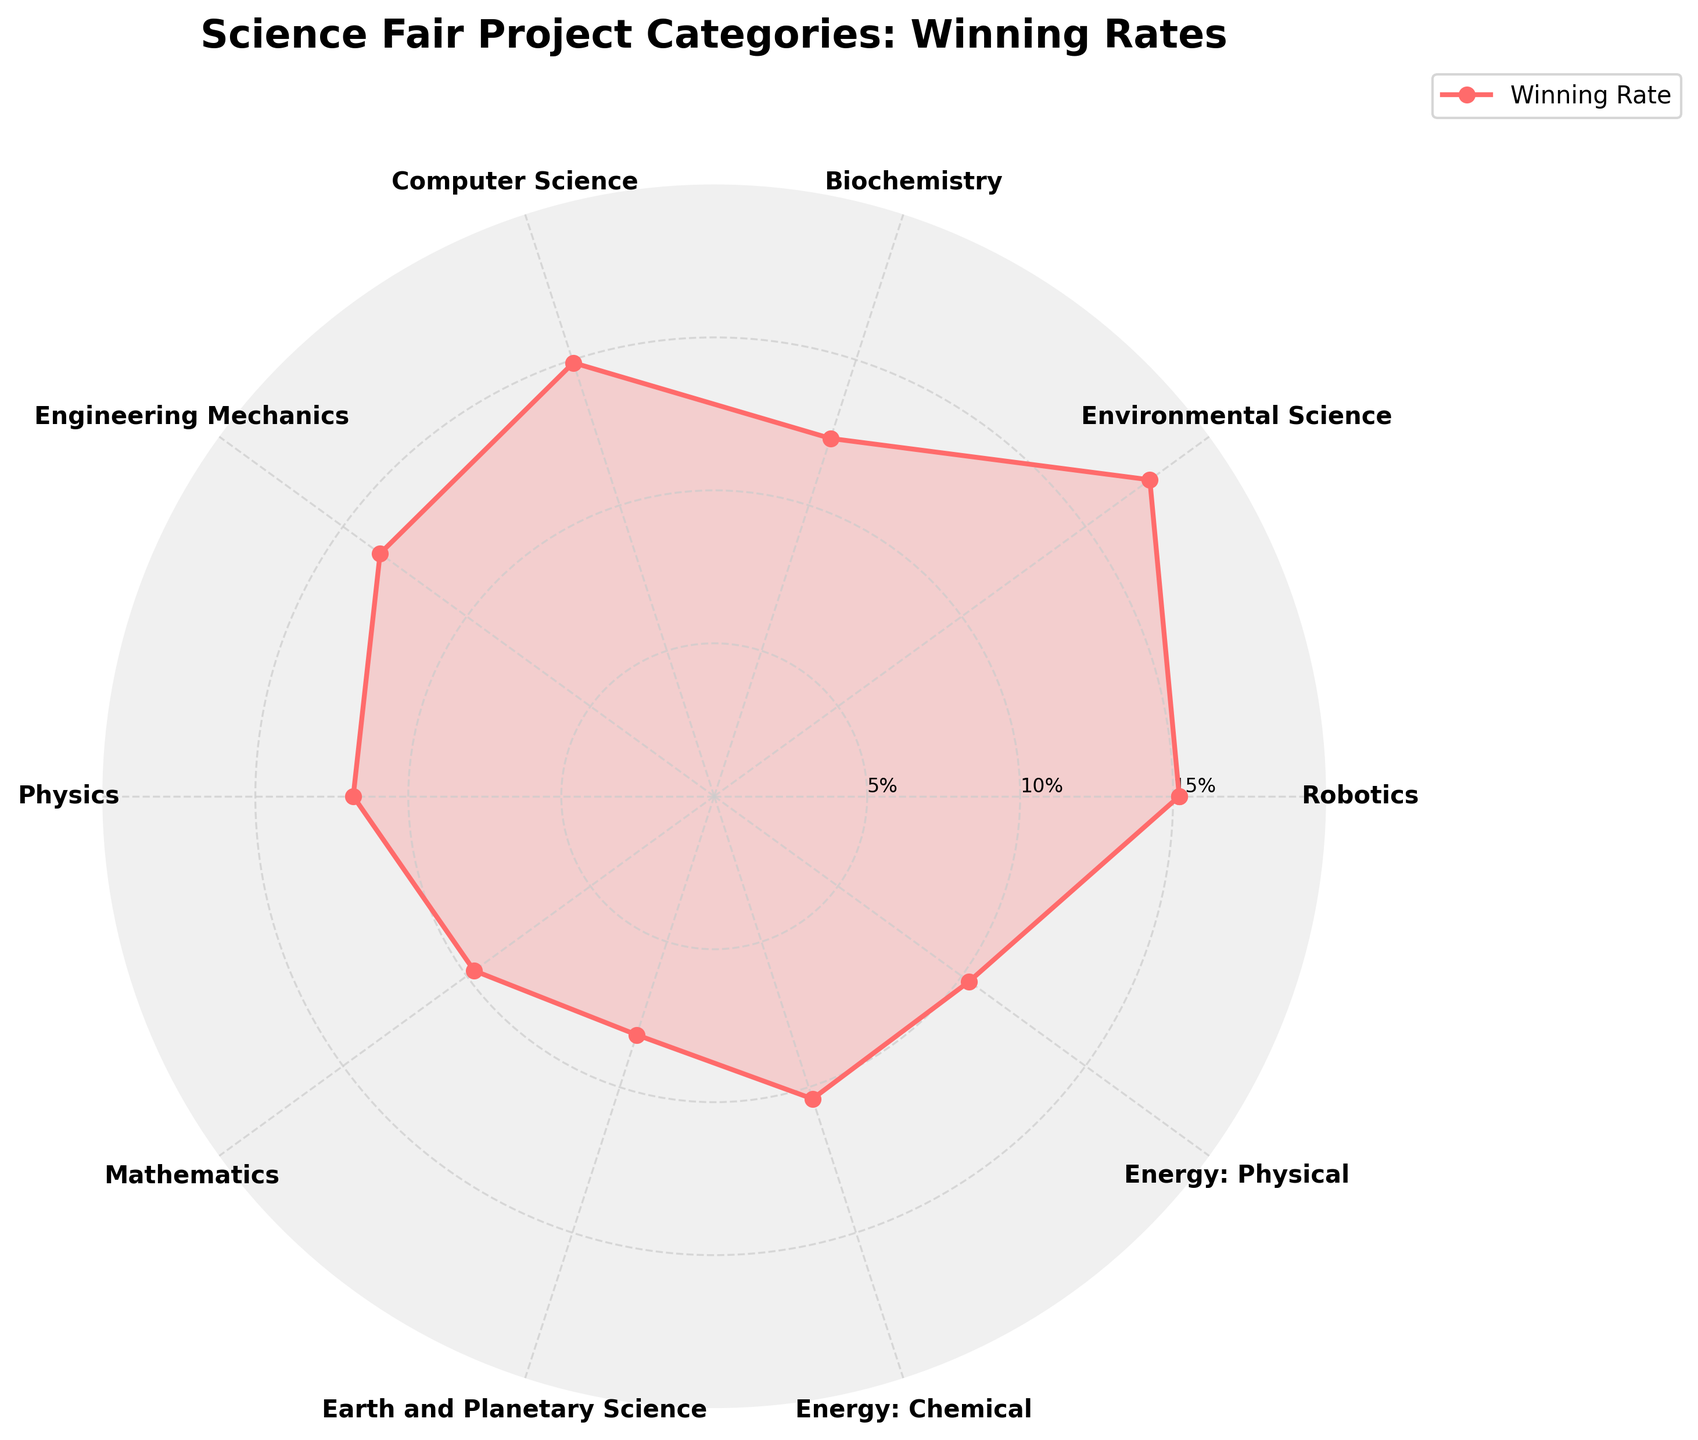How many categories are exhibited in the chart? Count the distinct segment labels around the chart, excluding any overlap. The total counts to ten categories as the chart shows one label for each category.
Answer: 10 What is the title of the chart? Observe the text at the top center of the chart. It states the purpose or subject of the chart.
Answer: Science Fair Project Categories: Winning Rates Which category has the highest winning rate? Locate the highest value on the radial axis and identify the corresponding category label from the circular segments.
Answer: Environmental Science What is the winning rate difference between Robotics and Physics? Find the values for Robotics (15.2) and Physics (11.8), then subtract the smaller from the larger: 15.2 - 11.8 = 3.4.
Answer: 3.4% Which categories have a winning rate less than 10%? Identify categories whose rates fall below the 10% radial mark by checking the segment labels.
Answer: Mathematics, Earth and Planetary Science Is there a significant difference in winning rates between Energy: Chemical and Energy: Physical? Compare the values for both categories: Energy: Chemical (10.4) and Energy: Physical (10.3), and find their difference: 10.4 - 10.3 = 0.1, which is not significant.
Answer: No How is the polar chart's data visually differentiated? Assess the visual elements like color, line style, fill, and grid used to represent data. Dashed lines and pink color fill distinguish the areas.
Answer: By color, line style, and fill What is the average winning rate across all categories? Sum the winning rates: 15.2 + 17.6 + 12.3 + 14.9 + 13.5 + 11.8 + 9.7 + 8.2 + 10.4 + 10.3 = 124.9, then divide by the number of categories (10): 124.9 / 10 = 12.49%.
Answer: 12.49% Calculate the total number of categories with winning rates above 12%. Identify and count the categories whose rates exceed 12%: Robotics (15.2), Environmental Science (17.6), Biochemistry (12.3), Computer Science (14.9), and Engineering Mechanics (13.5) total to 5 categories.
Answer: 5 Do Robotics and Engineering Mechanics have similar winning rates? Compare their values: Robotics (15.2) and Engineering Mechanics (13.5), and note the small difference of 1.7. While values are close, they are not the same.
Answer: Relatively similar 